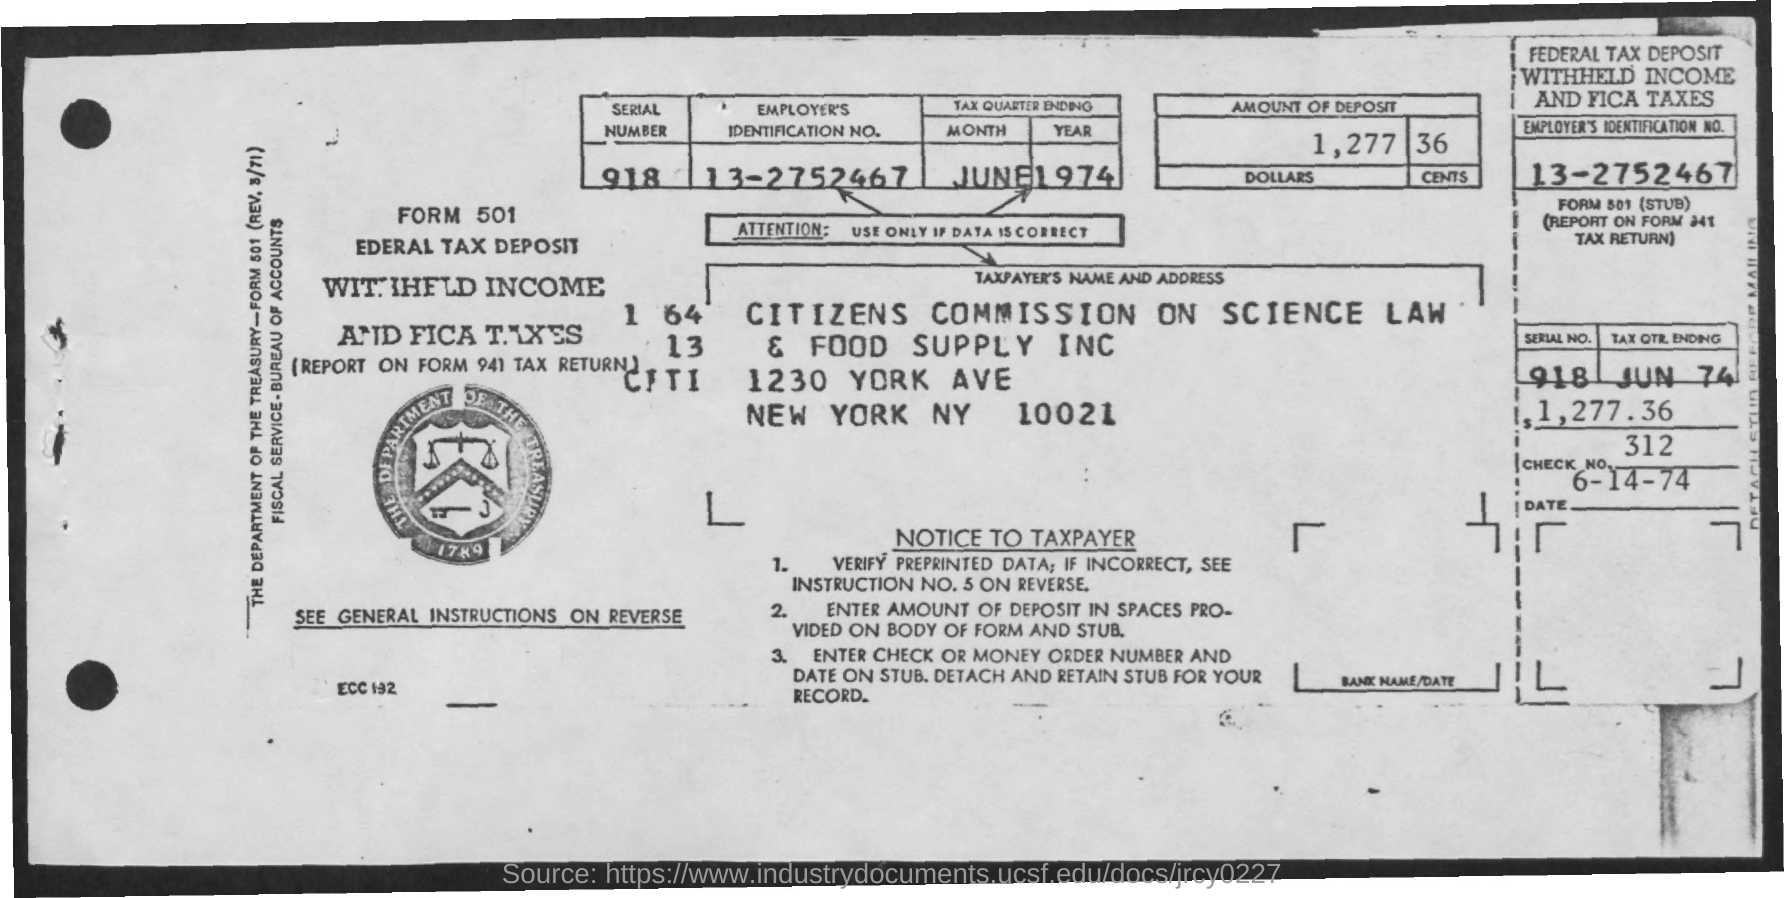What is the Check No.?
Provide a succinct answer. 312. What is the Employer's Identification No.?
Your answer should be compact. 13-2752467. What is the Serial No.?
Make the answer very short. 918. What is the Form Number?
Offer a terse response. 501. 